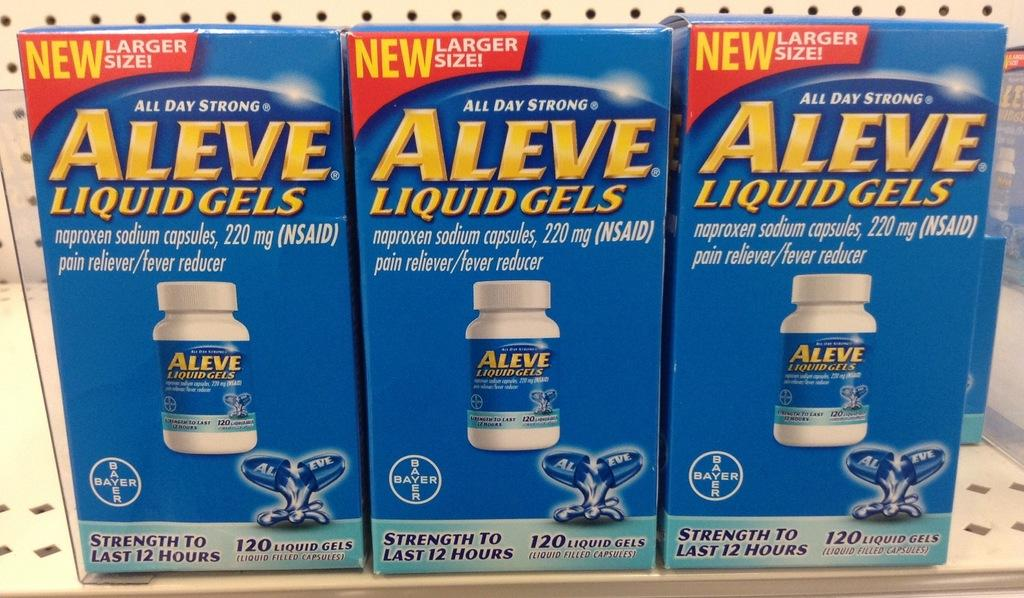<image>
Offer a succinct explanation of the picture presented. Three blue and yellow boxes of Aleve Liquid Gels 